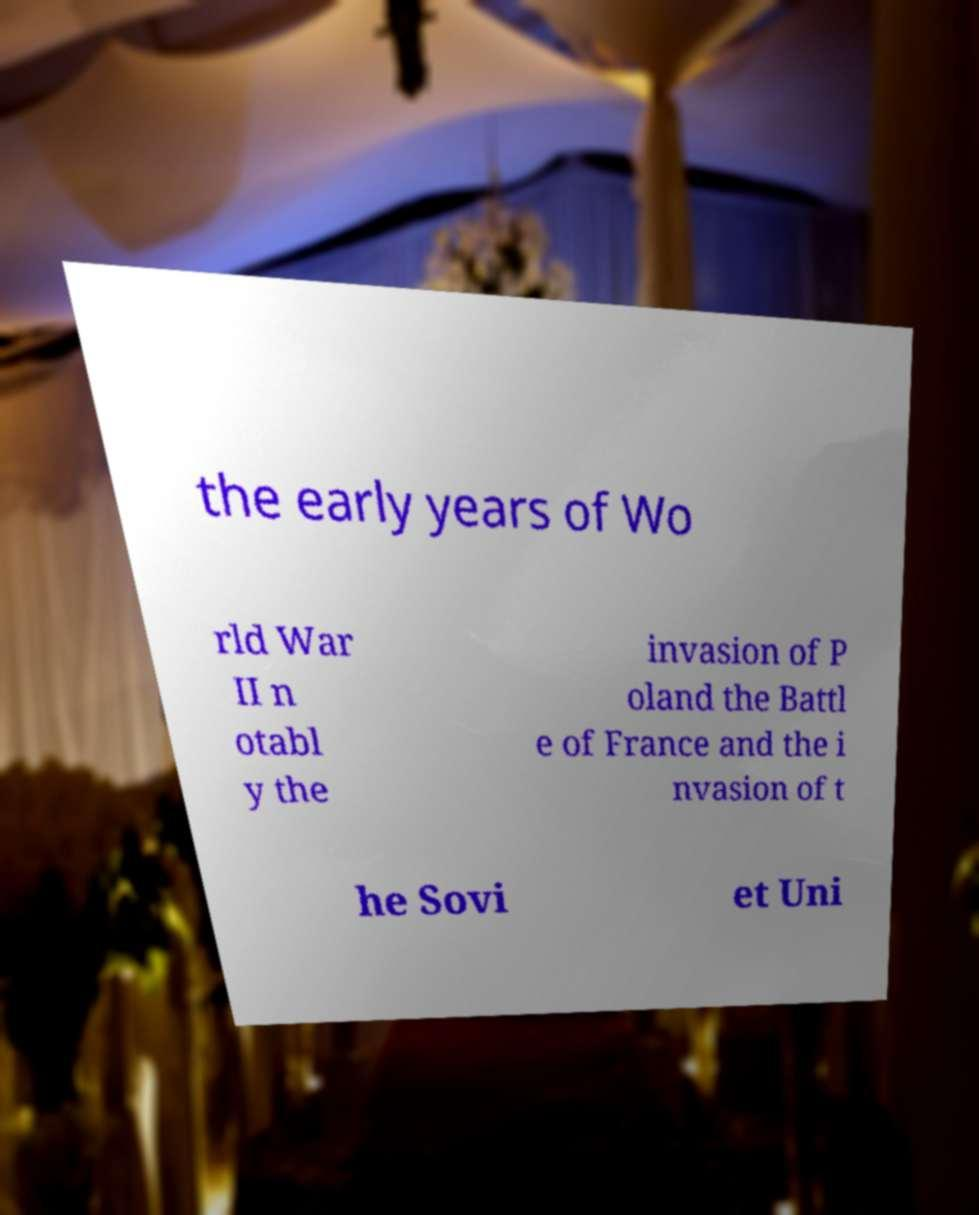Could you extract and type out the text from this image? the early years of Wo rld War II n otabl y the invasion of P oland the Battl e of France and the i nvasion of t he Sovi et Uni 